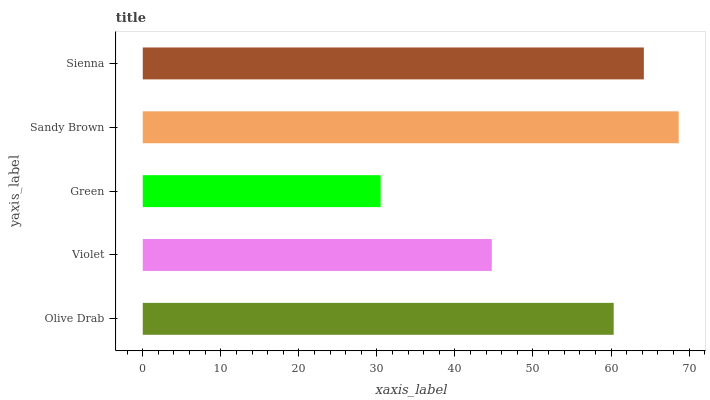Is Green the minimum?
Answer yes or no. Yes. Is Sandy Brown the maximum?
Answer yes or no. Yes. Is Violet the minimum?
Answer yes or no. No. Is Violet the maximum?
Answer yes or no. No. Is Olive Drab greater than Violet?
Answer yes or no. Yes. Is Violet less than Olive Drab?
Answer yes or no. Yes. Is Violet greater than Olive Drab?
Answer yes or no. No. Is Olive Drab less than Violet?
Answer yes or no. No. Is Olive Drab the high median?
Answer yes or no. Yes. Is Olive Drab the low median?
Answer yes or no. Yes. Is Green the high median?
Answer yes or no. No. Is Sienna the low median?
Answer yes or no. No. 